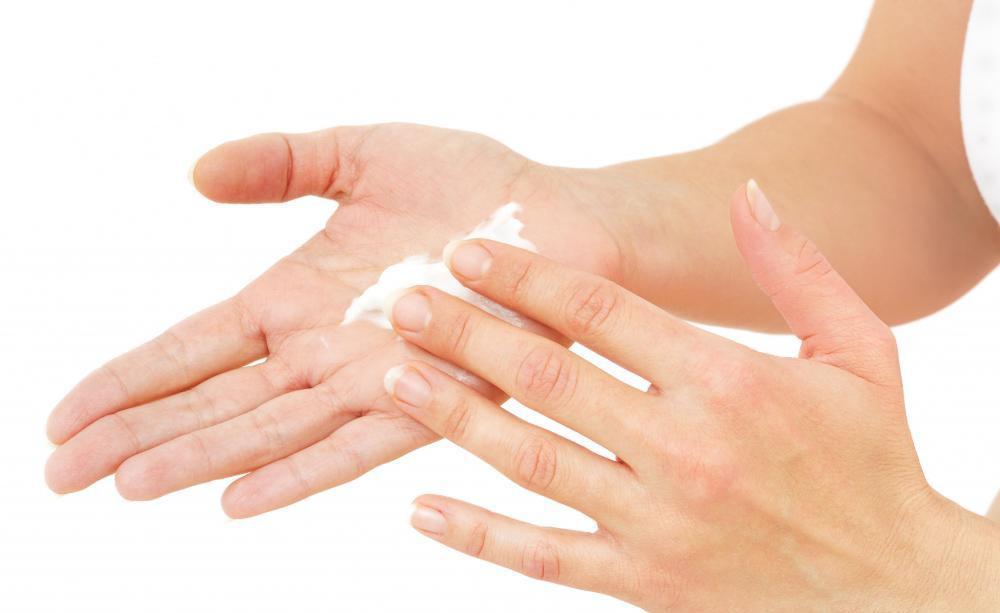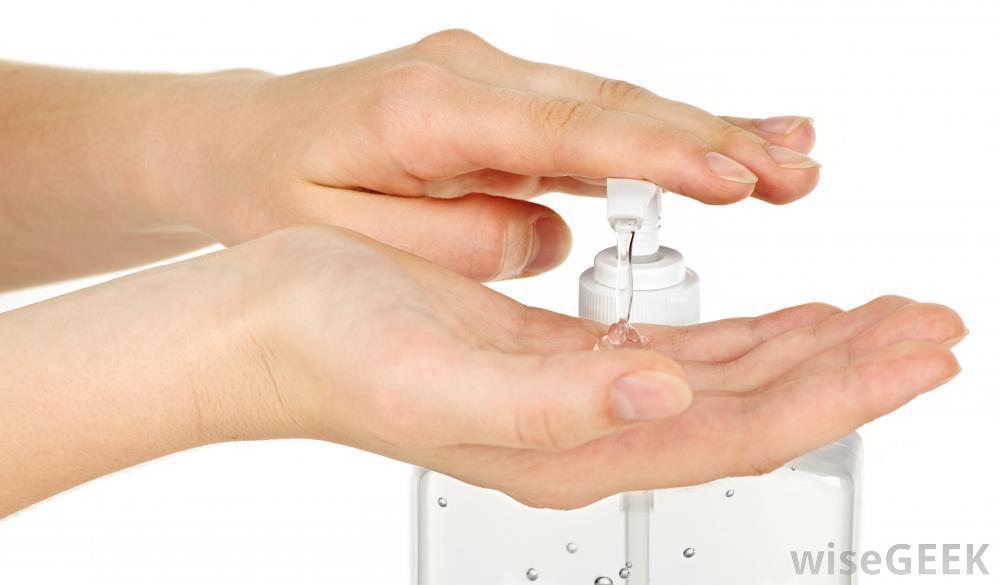The first image is the image on the left, the second image is the image on the right. Examine the images to the left and right. Is the description "The left and right image contains a total of four hands with lotion being rubbed on the back of one hand." accurate? Answer yes or no. No. The first image is the image on the left, the second image is the image on the right. Assess this claim about the two images: "In one of the images, one hand has a glob of white lotion in the palm.". Correct or not? Answer yes or no. Yes. 